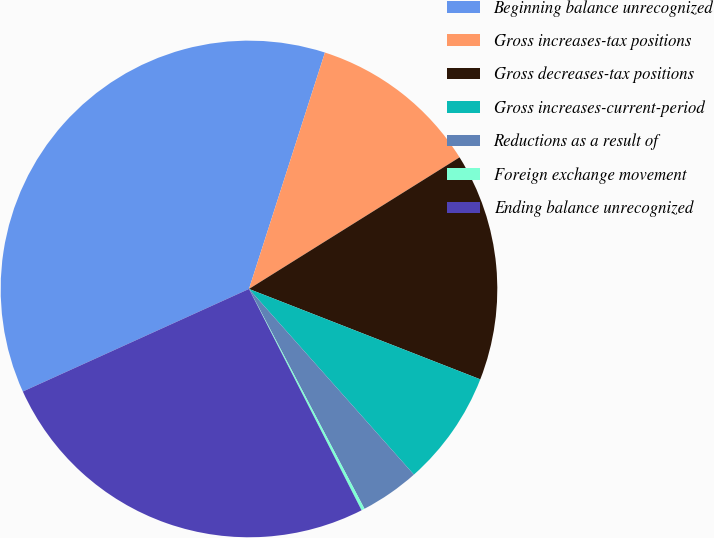Convert chart to OTSL. <chart><loc_0><loc_0><loc_500><loc_500><pie_chart><fcel>Beginning balance unrecognized<fcel>Gross increases-tax positions<fcel>Gross decreases-tax positions<fcel>Gross increases-current-period<fcel>Reductions as a result of<fcel>Foreign exchange movement<fcel>Ending balance unrecognized<nl><fcel>36.72%<fcel>11.16%<fcel>14.82%<fcel>7.51%<fcel>3.86%<fcel>0.21%<fcel>25.71%<nl></chart> 